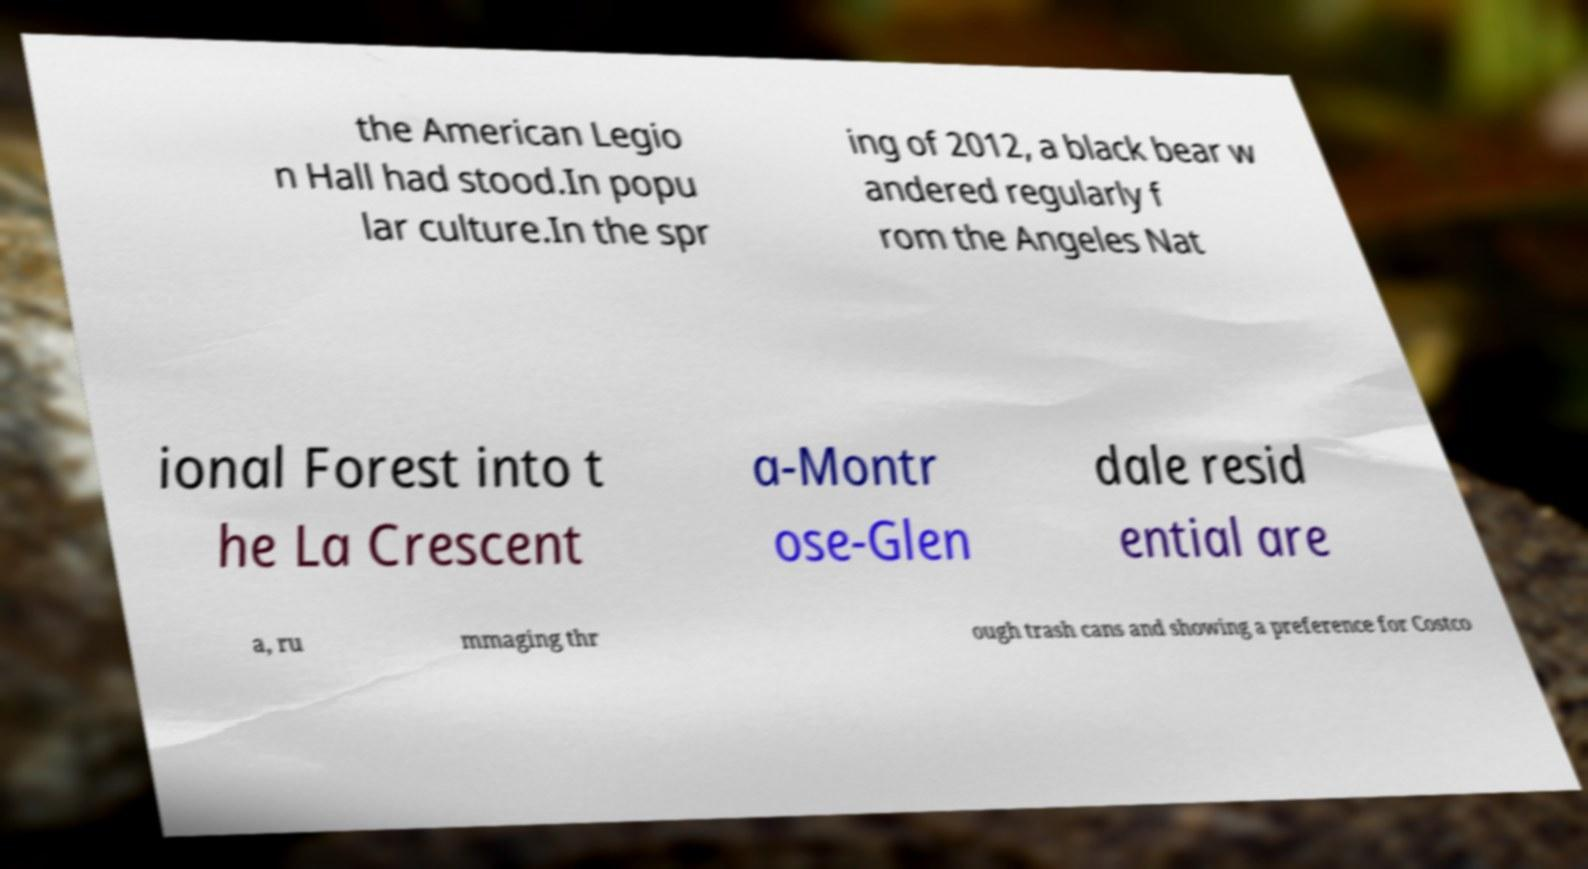For documentation purposes, I need the text within this image transcribed. Could you provide that? the American Legio n Hall had stood.In popu lar culture.In the spr ing of 2012, a black bear w andered regularly f rom the Angeles Nat ional Forest into t he La Crescent a-Montr ose-Glen dale resid ential are a, ru mmaging thr ough trash cans and showing a preference for Costco 